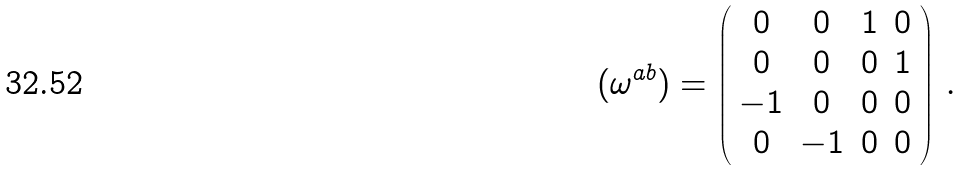Convert formula to latex. <formula><loc_0><loc_0><loc_500><loc_500>( \omega ^ { a b } ) = \left ( \begin{array} { c c c c } { 0 } & { 0 } & { 1 } & { 0 } \\ { 0 } & { 0 } & { 0 } & { 1 } \\ { - 1 } & { 0 } & { 0 } & { 0 } \\ { 0 } & { - 1 } & { 0 } & { 0 } \end{array} \right ) \, .</formula> 